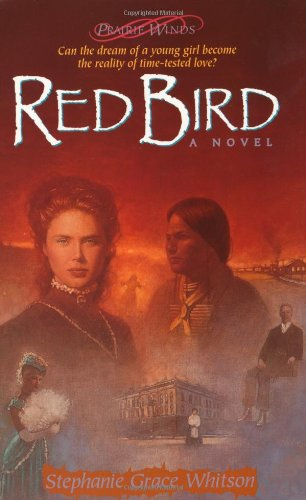What type of book is this? This book falls under the genre of Religion & Spirituality, exploring themes of faith, personal growth, and historical contexts within its narrative. 